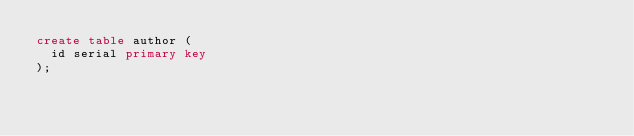Convert code to text. <code><loc_0><loc_0><loc_500><loc_500><_SQL_>create table author (
  id serial primary key
);</code> 